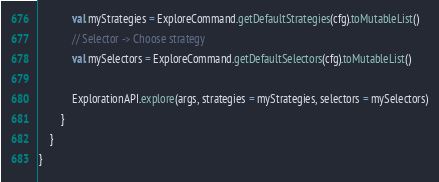<code> <loc_0><loc_0><loc_500><loc_500><_Kotlin_>            val myStrategies = ExploreCommand.getDefaultStrategies(cfg).toMutableList()
            // Selector -> Choose strategy
            val mySelectors = ExploreCommand.getDefaultSelectors(cfg).toMutableList()

            ExplorationAPI.explore(args, strategies = myStrategies, selectors = mySelectors)
        }
    }
}</code> 